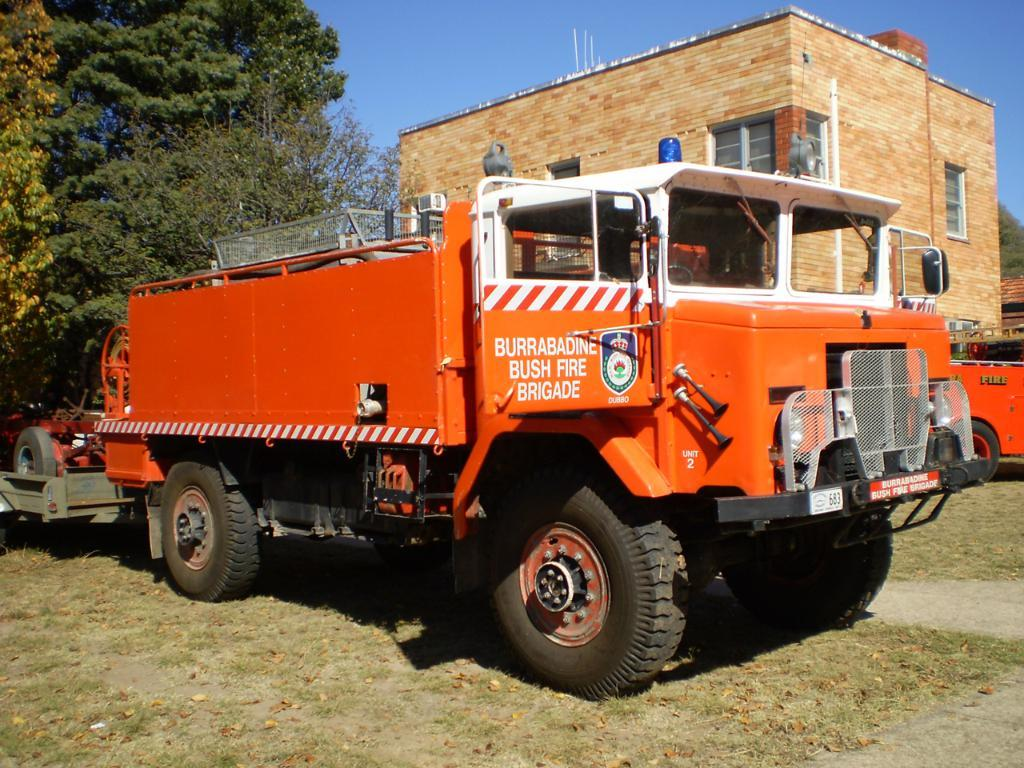What is the main subject of the image? The main subject of the image is a truck. Where is the truck located? The truck is on the land. What type of vegetation can be seen in the image? There are trees visible in the image. Can you describe the building in the image? There is a building with windows in the image. What is visible in the background of the image? The sky is visible in the image. What type of substance is being checked out at the library in the image? There is no library present in the image, so it is not possible to determine what type of substance might be checked out. 